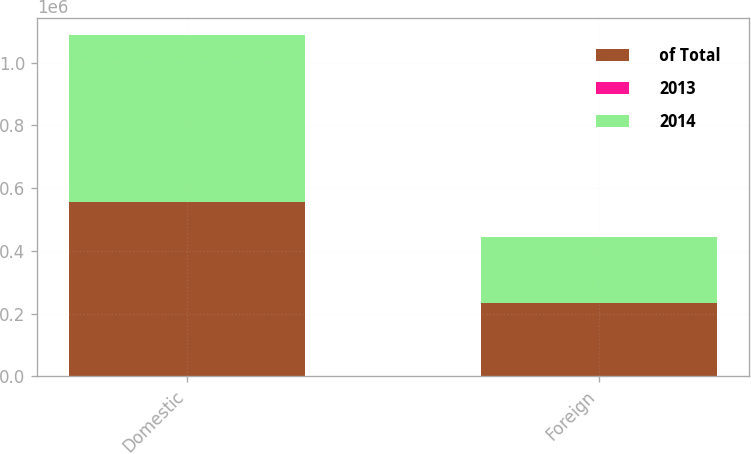<chart> <loc_0><loc_0><loc_500><loc_500><stacked_bar_chart><ecel><fcel>Domestic<fcel>Foreign<nl><fcel>of Total<fcel>556328<fcel>232450<nl><fcel>2013<fcel>70.5<fcel>29.5<nl><fcel>2014<fcel>530680<fcel>212306<nl></chart> 